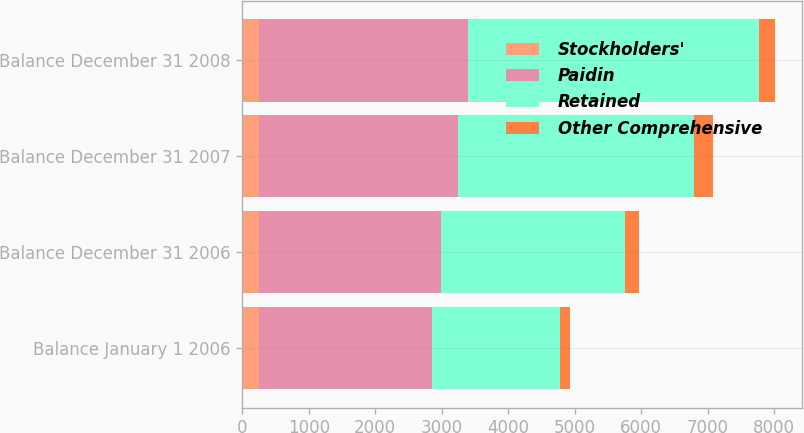<chart> <loc_0><loc_0><loc_500><loc_500><stacked_bar_chart><ecel><fcel>Balance January 1 2006<fcel>Balance December 31 2006<fcel>Balance December 31 2007<fcel>Balance December 31 2008<nl><fcel>Stockholders'<fcel>247.8<fcel>248.9<fcel>252.2<fcel>253.7<nl><fcel>Paidin<fcel>2601.1<fcel>2743.2<fcel>2999.1<fcel>3138.5<nl><fcel>Retained<fcel>1934<fcel>2768.5<fcel>3536.9<fcel>4385.5<nl><fcel>Other Comprehensive<fcel>149.3<fcel>209.2<fcel>290.3<fcel>240<nl></chart> 